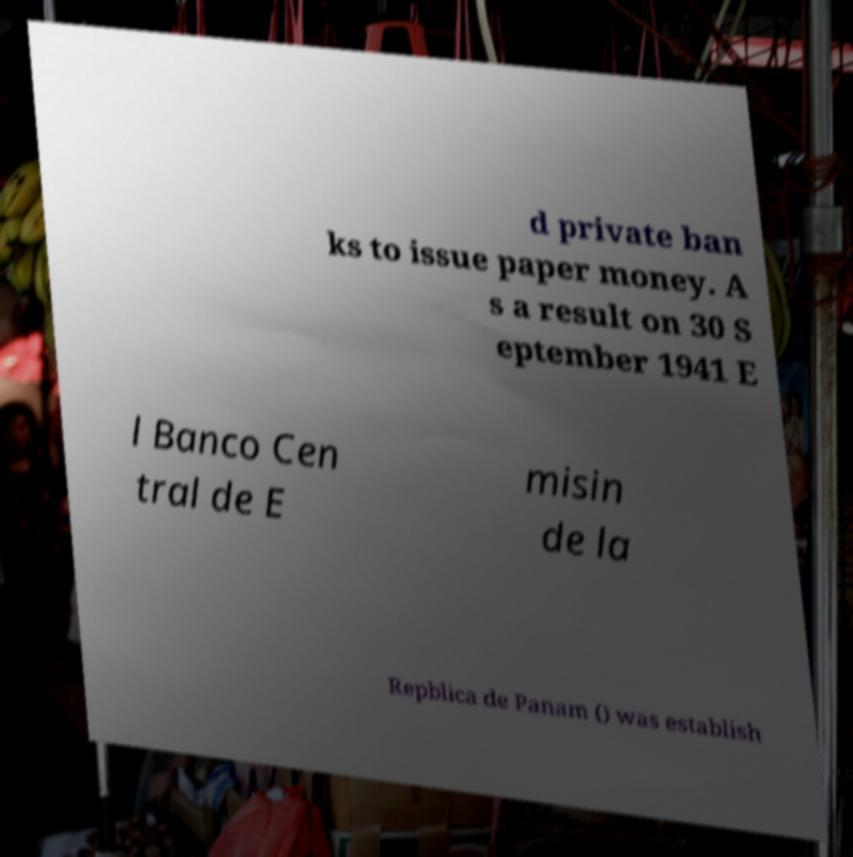There's text embedded in this image that I need extracted. Can you transcribe it verbatim? d private ban ks to issue paper money. A s a result on 30 S eptember 1941 E l Banco Cen tral de E misin de la Repblica de Panam () was establish 